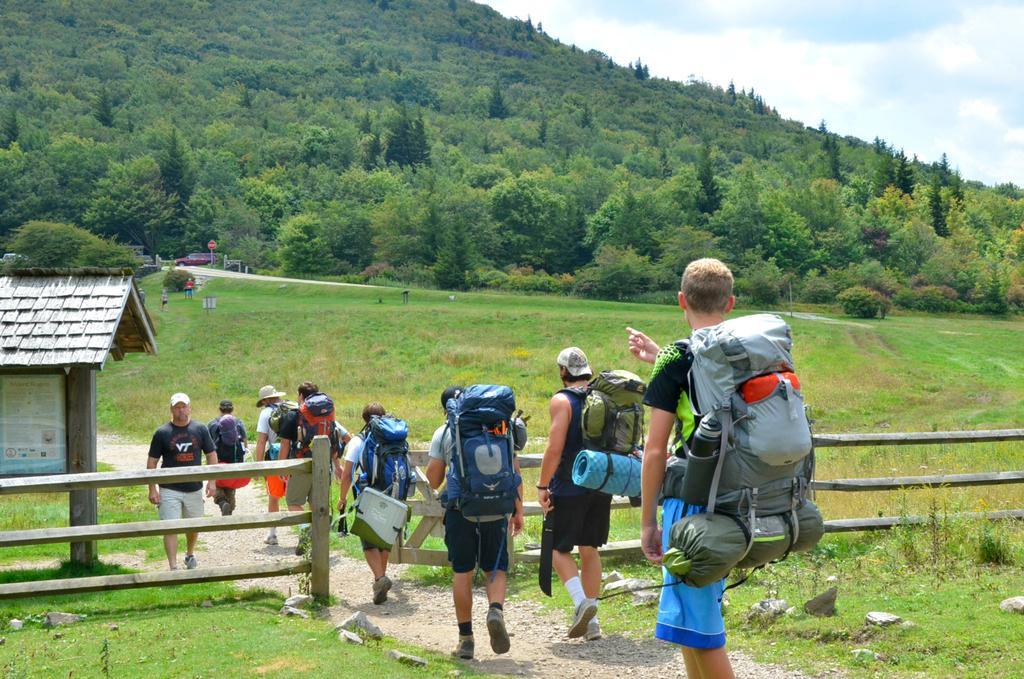In one or two sentences, can you explain what this image depicts? In this image there are few people walking on the path with their luggages, there is a house and a wooden fence. In the background there is a vehicle on the road, grass, trees and the sky. 